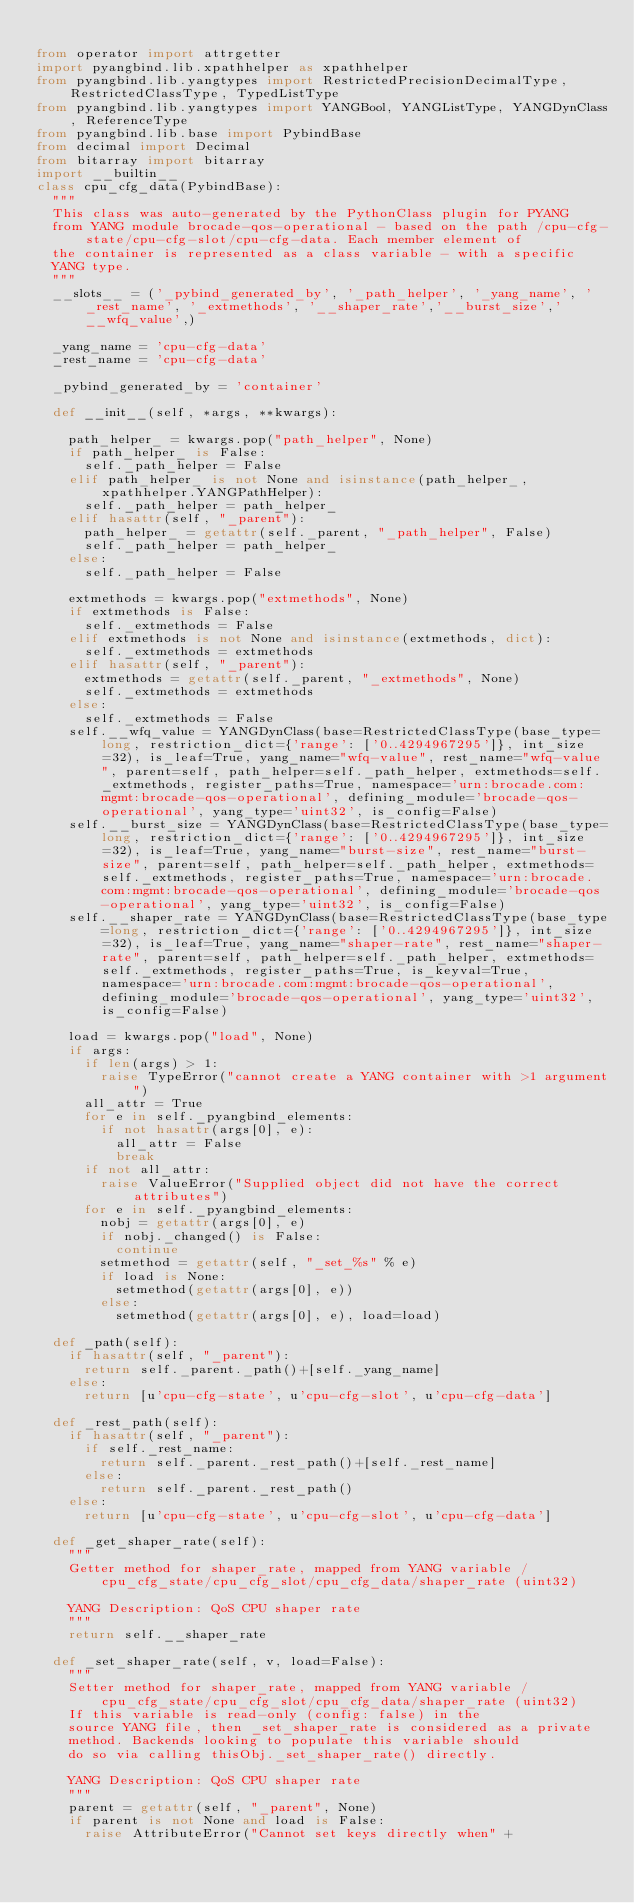Convert code to text. <code><loc_0><loc_0><loc_500><loc_500><_Python_>
from operator import attrgetter
import pyangbind.lib.xpathhelper as xpathhelper
from pyangbind.lib.yangtypes import RestrictedPrecisionDecimalType, RestrictedClassType, TypedListType
from pyangbind.lib.yangtypes import YANGBool, YANGListType, YANGDynClass, ReferenceType
from pyangbind.lib.base import PybindBase
from decimal import Decimal
from bitarray import bitarray
import __builtin__
class cpu_cfg_data(PybindBase):
  """
  This class was auto-generated by the PythonClass plugin for PYANG
  from YANG module brocade-qos-operational - based on the path /cpu-cfg-state/cpu-cfg-slot/cpu-cfg-data. Each member element of
  the container is represented as a class variable - with a specific
  YANG type.
  """
  __slots__ = ('_pybind_generated_by', '_path_helper', '_yang_name', '_rest_name', '_extmethods', '__shaper_rate','__burst_size','__wfq_value',)

  _yang_name = 'cpu-cfg-data'
  _rest_name = 'cpu-cfg-data'

  _pybind_generated_by = 'container'

  def __init__(self, *args, **kwargs):

    path_helper_ = kwargs.pop("path_helper", None)
    if path_helper_ is False:
      self._path_helper = False
    elif path_helper_ is not None and isinstance(path_helper_, xpathhelper.YANGPathHelper):
      self._path_helper = path_helper_
    elif hasattr(self, "_parent"):
      path_helper_ = getattr(self._parent, "_path_helper", False)
      self._path_helper = path_helper_
    else:
      self._path_helper = False

    extmethods = kwargs.pop("extmethods", None)
    if extmethods is False:
      self._extmethods = False
    elif extmethods is not None and isinstance(extmethods, dict):
      self._extmethods = extmethods
    elif hasattr(self, "_parent"):
      extmethods = getattr(self._parent, "_extmethods", None)
      self._extmethods = extmethods
    else:
      self._extmethods = False
    self.__wfq_value = YANGDynClass(base=RestrictedClassType(base_type=long, restriction_dict={'range': ['0..4294967295']}, int_size=32), is_leaf=True, yang_name="wfq-value", rest_name="wfq-value", parent=self, path_helper=self._path_helper, extmethods=self._extmethods, register_paths=True, namespace='urn:brocade.com:mgmt:brocade-qos-operational', defining_module='brocade-qos-operational', yang_type='uint32', is_config=False)
    self.__burst_size = YANGDynClass(base=RestrictedClassType(base_type=long, restriction_dict={'range': ['0..4294967295']}, int_size=32), is_leaf=True, yang_name="burst-size", rest_name="burst-size", parent=self, path_helper=self._path_helper, extmethods=self._extmethods, register_paths=True, namespace='urn:brocade.com:mgmt:brocade-qos-operational', defining_module='brocade-qos-operational', yang_type='uint32', is_config=False)
    self.__shaper_rate = YANGDynClass(base=RestrictedClassType(base_type=long, restriction_dict={'range': ['0..4294967295']}, int_size=32), is_leaf=True, yang_name="shaper-rate", rest_name="shaper-rate", parent=self, path_helper=self._path_helper, extmethods=self._extmethods, register_paths=True, is_keyval=True, namespace='urn:brocade.com:mgmt:brocade-qos-operational', defining_module='brocade-qos-operational', yang_type='uint32', is_config=False)

    load = kwargs.pop("load", None)
    if args:
      if len(args) > 1:
        raise TypeError("cannot create a YANG container with >1 argument")
      all_attr = True
      for e in self._pyangbind_elements:
        if not hasattr(args[0], e):
          all_attr = False
          break
      if not all_attr:
        raise ValueError("Supplied object did not have the correct attributes")
      for e in self._pyangbind_elements:
        nobj = getattr(args[0], e)
        if nobj._changed() is False:
          continue
        setmethod = getattr(self, "_set_%s" % e)
        if load is None:
          setmethod(getattr(args[0], e))
        else:
          setmethod(getattr(args[0], e), load=load)

  def _path(self):
    if hasattr(self, "_parent"):
      return self._parent._path()+[self._yang_name]
    else:
      return [u'cpu-cfg-state', u'cpu-cfg-slot', u'cpu-cfg-data']

  def _rest_path(self):
    if hasattr(self, "_parent"):
      if self._rest_name:
        return self._parent._rest_path()+[self._rest_name]
      else:
        return self._parent._rest_path()
    else:
      return [u'cpu-cfg-state', u'cpu-cfg-slot', u'cpu-cfg-data']

  def _get_shaper_rate(self):
    """
    Getter method for shaper_rate, mapped from YANG variable /cpu_cfg_state/cpu_cfg_slot/cpu_cfg_data/shaper_rate (uint32)

    YANG Description: QoS CPU shaper rate
    """
    return self.__shaper_rate
      
  def _set_shaper_rate(self, v, load=False):
    """
    Setter method for shaper_rate, mapped from YANG variable /cpu_cfg_state/cpu_cfg_slot/cpu_cfg_data/shaper_rate (uint32)
    If this variable is read-only (config: false) in the
    source YANG file, then _set_shaper_rate is considered as a private
    method. Backends looking to populate this variable should
    do so via calling thisObj._set_shaper_rate() directly.

    YANG Description: QoS CPU shaper rate
    """
    parent = getattr(self, "_parent", None)
    if parent is not None and load is False:
      raise AttributeError("Cannot set keys directly when" +</code> 